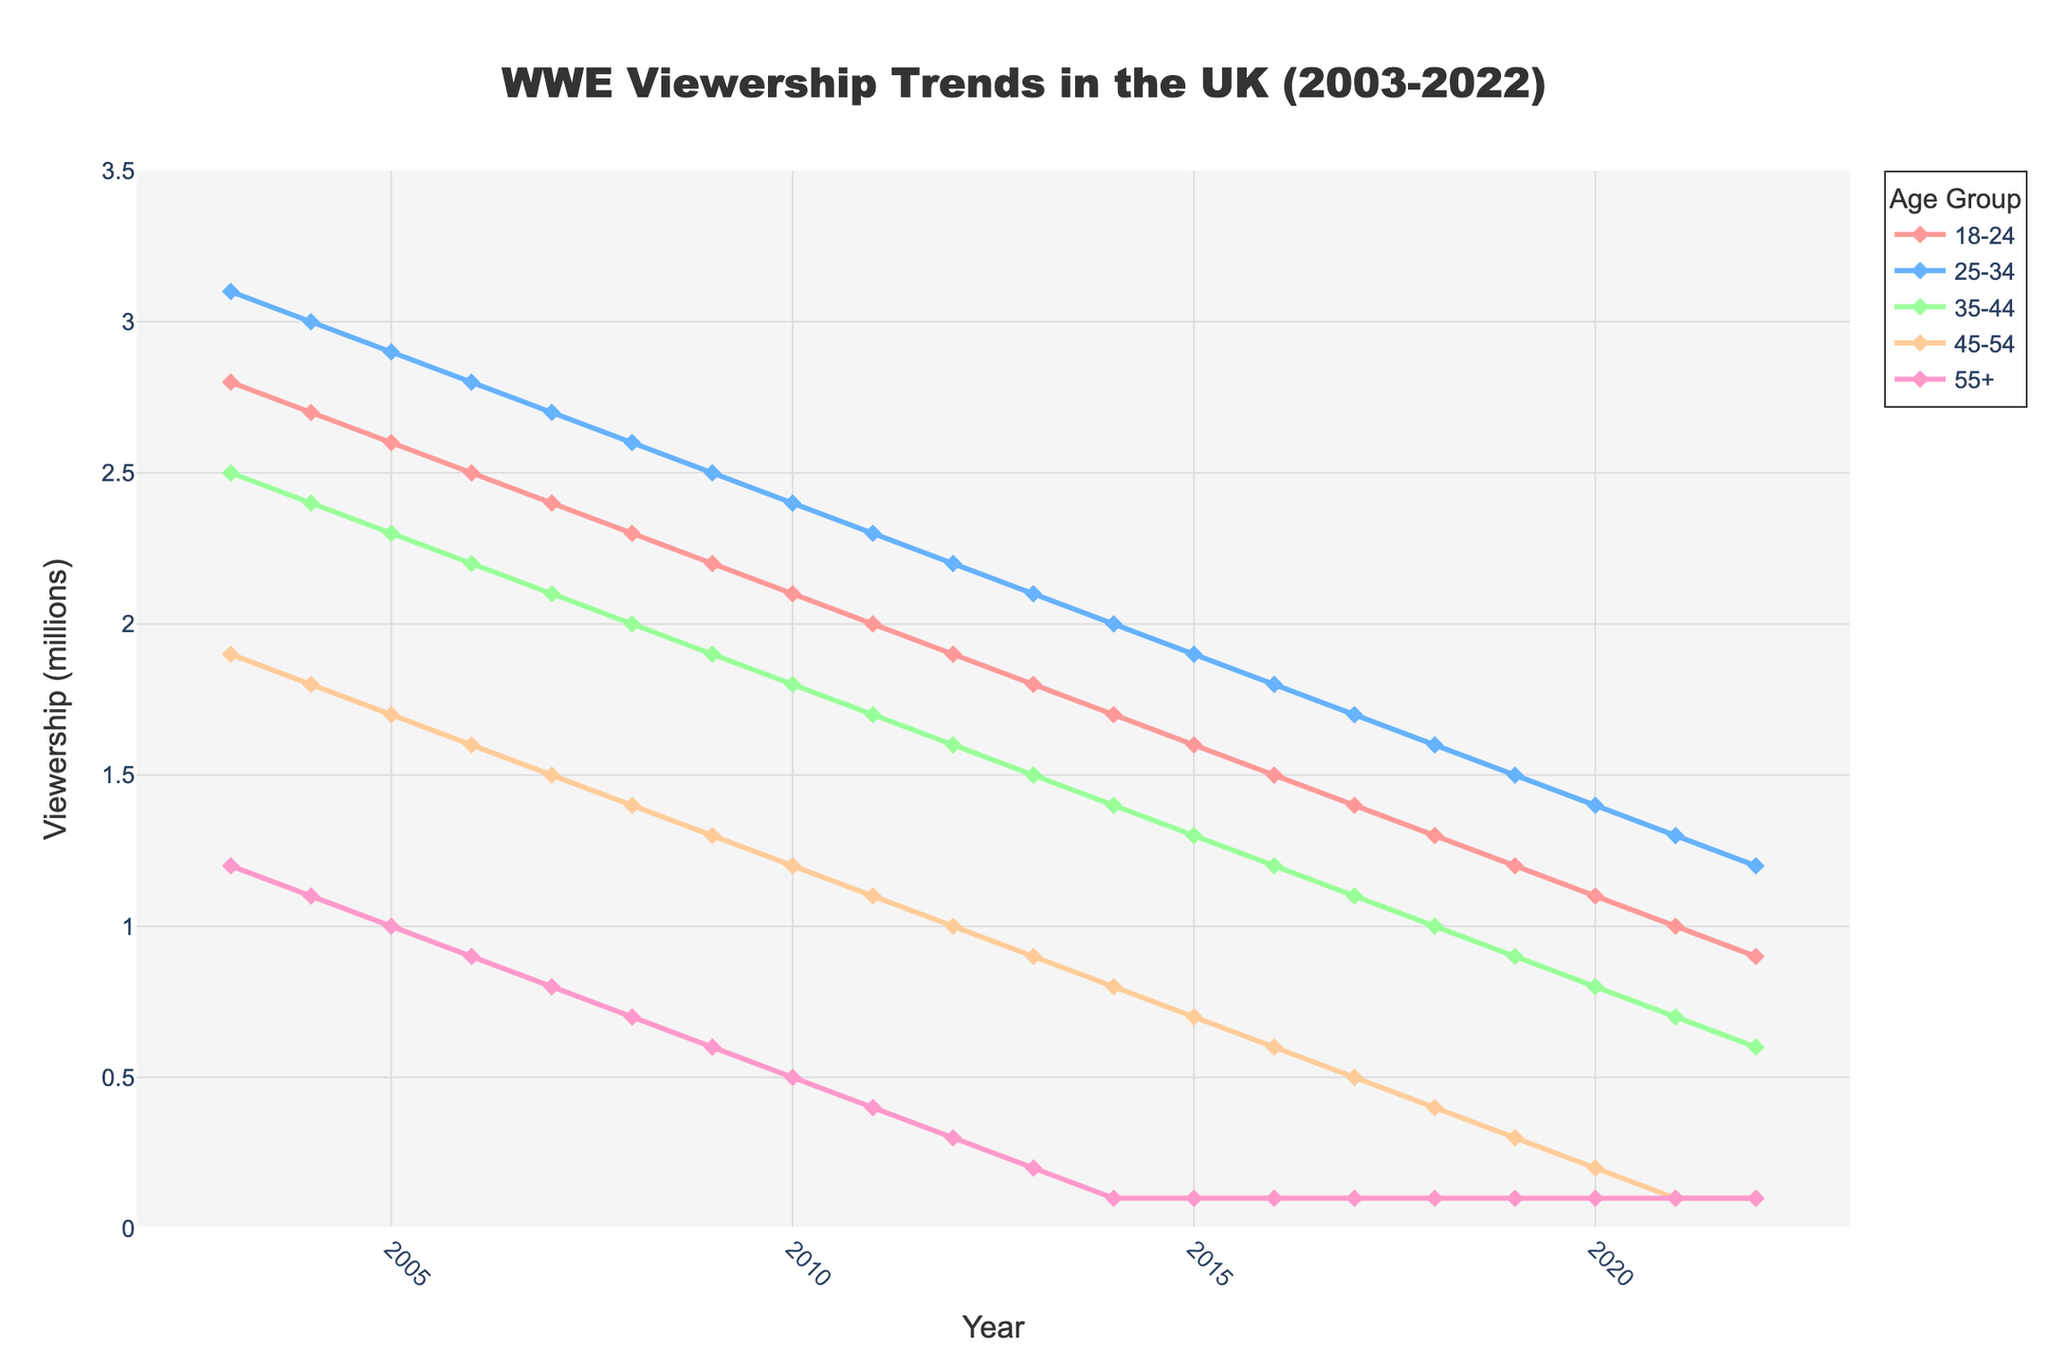Which age group had the highest viewership in 2003? Look at the data points for the year 2003 and compare the values across different age groups. The highest value is for the 25-34 age group.
Answer: 25-34 age group How many age groups had a viewership of less than 1 million in 2022? Check the data for the year 2022 and count the number of age groups with viewership values below 1 million. There are 3 such age groups: 45-54, and 55+.
Answer: 3 age groups Between which years did the 18-24 age group see the largest decrease in viewership? Calculate the annual difference in viewership for the 18-24 age group by finding the difference between consecutive years. The largest decrease happened between 2019 and 2020, dropping from 1.2 to 1.1 million.
Answer: Between 2019 and 2020 By how much did the viewership of the 25-34 age group decline from 2003 to 2022? Subtract the viewership in 2022 from the viewership in 2003 for the 25-34 age group. The decline is 3.1 million - 1.2 million = 1.9 million.
Answer: 1.9 million What is the average viewership for the 35-44 age group over the period 2003 to 2022? Calculate the average by summing the viewership values for the 35-44 age group from 2003 to 2022 and then dividing by the number of years (20). The sum is 2.5 + 2.4 + 2.3 + 2.2 + 2.1 + 2.0 + 1.9 + 1.8 + 1.7 + 1.6 + 1.5 + 1.4 + 1.3 + 1.2 + 1.1 + 1.0 + 0.9 + 0.8 + 0.7 + 0.6 = 36.5, so the average is 36.5/20 = 1.825 million.
Answer: 1.825 million Did the viewership of any age group increase over the period from 2003 to 2022? Observe the trends for each age group from 2003 to 2022. There are no increasing trends; every age group shows a declining viewership over this period.
Answer: No Which age group had the lowest viewership in 2012? Check the viewership values for each age group in the year 2012. The lowest viewership is 0.3 million for the 55+ age group.
Answer: 55+ age group Is the rate of decline in viewership similar across all age groups? Compare the decrements in viewership values for each age group over the years from 2003 to 2022. The decline rates differ, with younger age groups (18-24, 25-34) having a gradual decline, while older age groups (55+) show a steeper decline.
Answer: No What was the viewership difference between the 45-54 and 55+ age groups in 2010? Subtract the viewership of the 55+ age group from the 45-54 age group in 2010. The difference is 1.2 million - 0.5 million = 0.7 million.
Answer: 0.7 million 